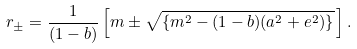Convert formula to latex. <formula><loc_0><loc_0><loc_500><loc_500>r _ { \pm } = \frac { 1 } { ( 1 - b ) } \left [ m \pm \sqrt { \{ m ^ { 2 } - ( 1 - b ) ( a ^ { 2 } + e ^ { 2 } ) \} } \, \right ] .</formula> 